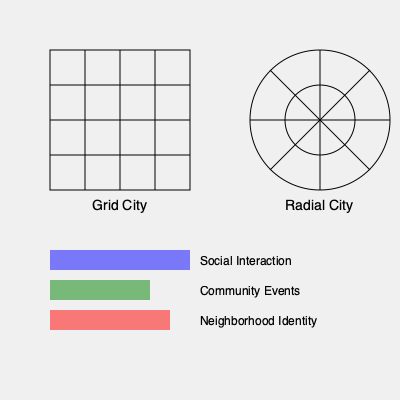Based on the urban layouts shown in the diagram, which city design is likely to promote higher social cohesion, and why? Consider the impact of physical space on social dynamics and provide at least two supporting arguments. To answer this question, we need to analyze how the physical layout of a city influences social interactions and community formation. Let's examine both designs:

1. Grid City:
   - Promotes efficiency in navigation and transportation
   - Creates distinct neighborhoods with clear boundaries
   - May limit random interactions due to linear pathways

2. Radial City:
   - Encourages convergence towards a central point
   - Creates a hierarchy of spaces (center to periphery)
   - Allows for more varied and spontaneous movement patterns

Now, let's consider how these designs affect social cohesion:

a) Social Interaction:
   - Radial design encourages more diverse paths and potential for random encounters
   - Central areas in radial designs often become natural gathering points

b) Community Events:
   - Radial design provides natural focal points for community events
   - Concentric circles can create multi-use spaces of varying sizes

c) Neighborhood Identity:
   - Grid design may create stronger local neighborhood identities
   - Radial design promotes a stronger overall city identity

d) Physical Proximity:
   - Radial design often results in higher population density near the center
   - Increased density can lead to more frequent social interactions

e) Accessibility:
   - Radial design typically provides easier access to central areas from all parts of the city
   - This can promote a sense of shared urban experience

Considering these factors, the radial city design is likely to promote higher social cohesion. It encourages more diverse interactions, provides natural gathering spaces, and fosters a stronger overall city identity. The convergence towards a central area and the varied movement patterns can lead to more spontaneous social encounters and a greater sense of shared urban experience.
Answer: Radial city design promotes higher social cohesion due to increased diverse interactions and natural central gathering spaces. 